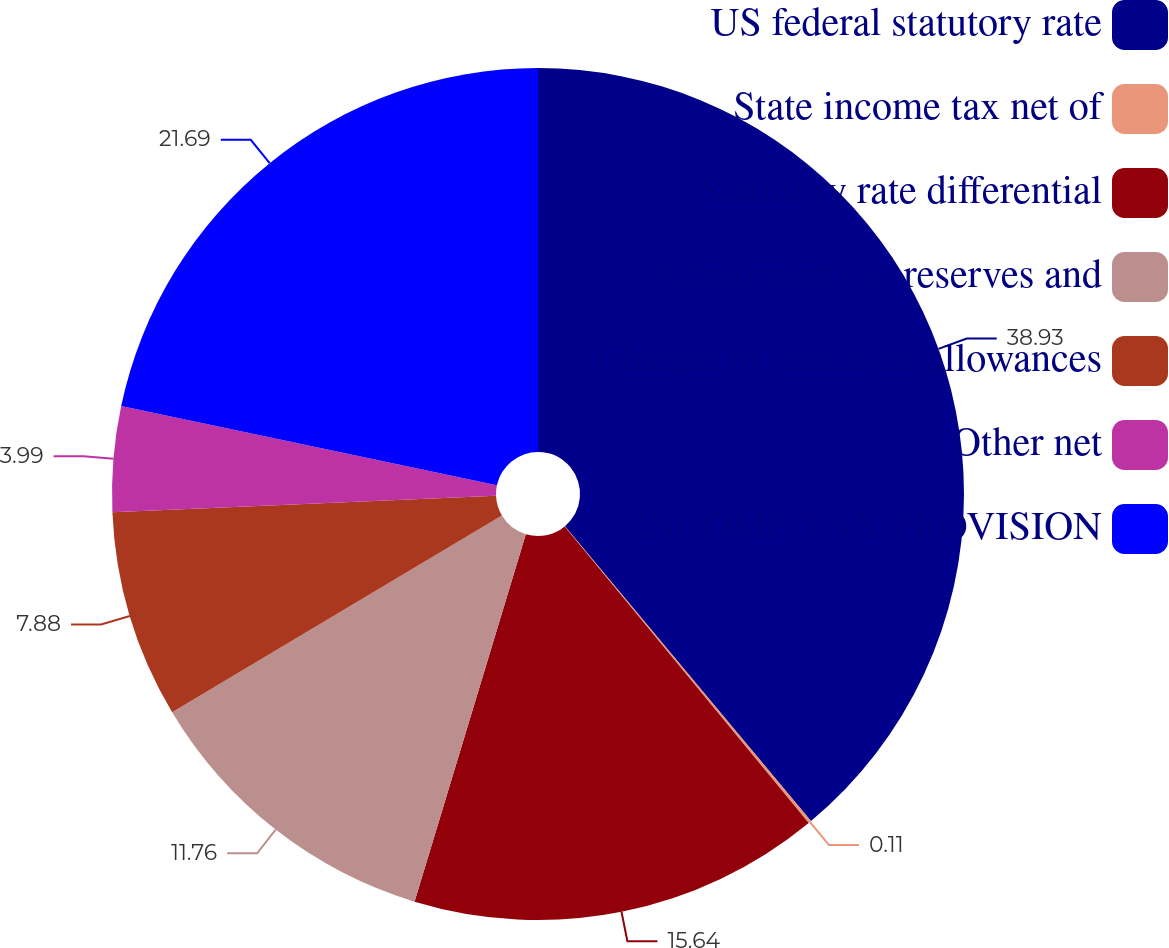<chart> <loc_0><loc_0><loc_500><loc_500><pie_chart><fcel>US federal statutory rate<fcel>State income tax net of<fcel>Statutory rate differential<fcel>Adjustments to reserves and<fcel>Change in valuation allowances<fcel>Other net<fcel>INCOME TAX PROVISION<nl><fcel>38.93%<fcel>0.11%<fcel>15.64%<fcel>11.76%<fcel>7.88%<fcel>3.99%<fcel>21.69%<nl></chart> 